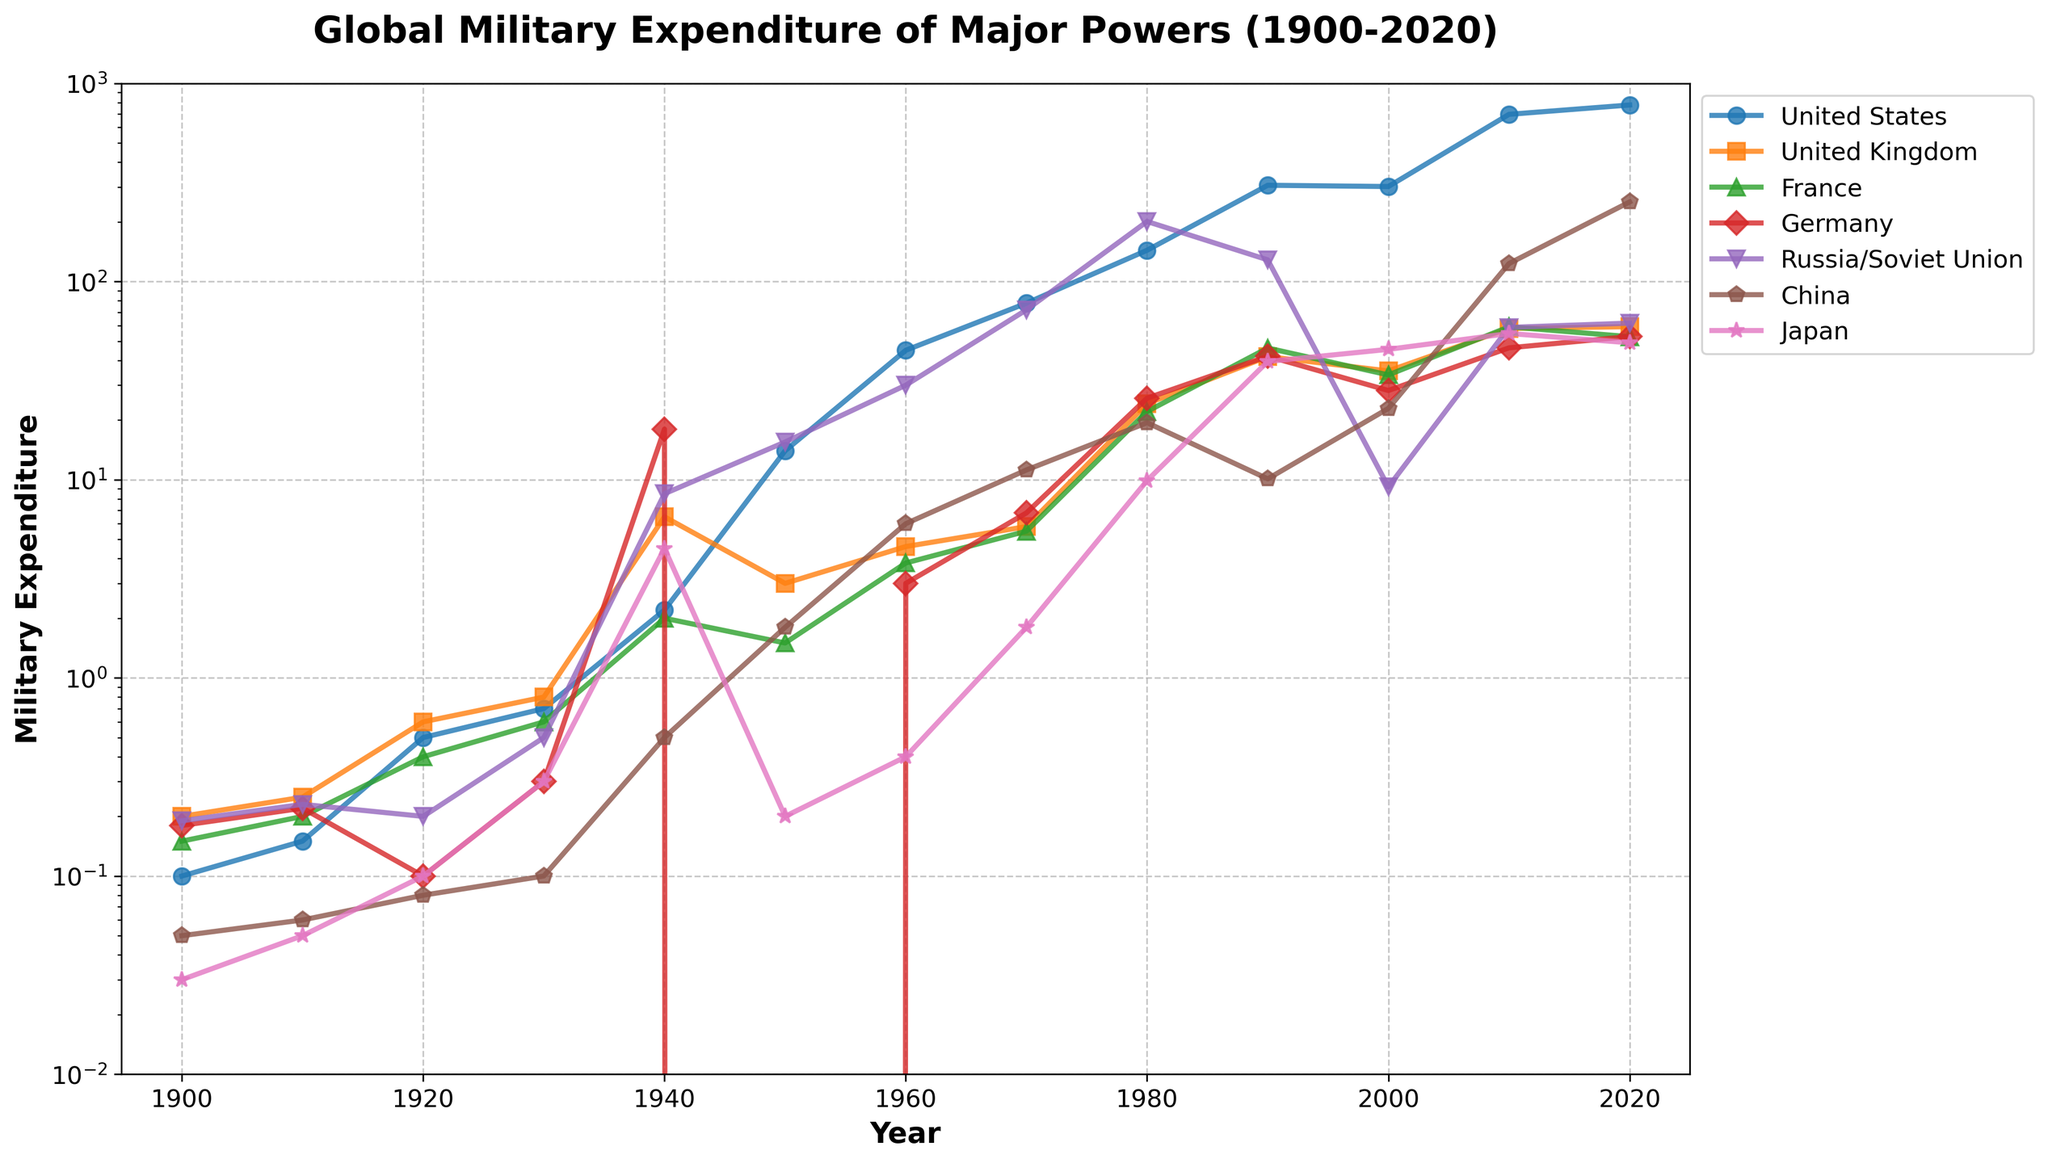When did the United States see its sharpest increase in military expenditure? To determine the sharpest increase, we need to look for the steepest slope in the plot line for the United States. The line rises most sharply between 1940 and 1950.
Answer: 1940-1950 What was Germany's military expenditure in 1950 compared to 1940? In 1940, Germany's expenditure was 18.0, and in 1950, it was 0.0. The comparison shows it dropped to zero after WWII.
Answer: Dropped to zero During which decade did China's military expenditure surpass that of France? By closely looking at the lines for China and France, we see that China's expenditure surpasses France's expenditure in the 2000s.
Answer: 2000s Which country had the highest military expenditure in 1980, and how much was it? Looking at the heights of the lines for each country in 1980, Russia/Soviet Union had the highest expenditure at 201.0.
Answer: Russia/Soviet Union, 201.0 How did Japan's military expenditure change from 1990 to 2000? Japan's expenditure increased from 39.5 in 1990 to 45.5 in 2000.
Answer: Increased What is the average military expenditure for the United Kingdom from 2000 to 2020? The expenditures are 35.4, 58.0, and 59.2. Adding them gives 152.6, and dividing by 3 gives approximately 50.87.
Answer: 50.87 Compare the military expenditures of the United States and China in 2020. The plot shows that the United States has an expenditure of 778.2, while China has 252.3, making the US expenditure significantly higher.
Answer: United States is higher Which country experienced a significant peak in military expenditure during the 1940s, and what might be the historical reason? Germany's expenditure peaks at 18.0 in 1940, which aligns with its involvement in WWII.
Answer: Germany, WWII What was the trend in the Soviet Union/Russia's military expenditure from 1980 to 2000? The Soviet Union's expenditure decreases from 201.0 in 1980 to 128.7 in 1990 and sharply drops to 9.2 in 2000.
Answer: Downward trend Which two countries had similar military expenditures in 1960? France and Germany had expenditures of 3.8 and 3.0, respectively, which are close to each other.
Answer: France and Germany 